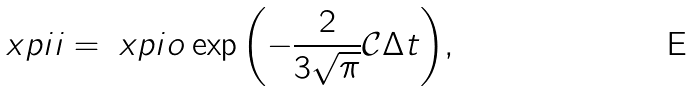<formula> <loc_0><loc_0><loc_500><loc_500>\ x p i i = \ x p i o \exp { \left ( - \frac { 2 } { 3 \sqrt { \pi } } \mathcal { C } \Delta t \right ) } ,</formula> 